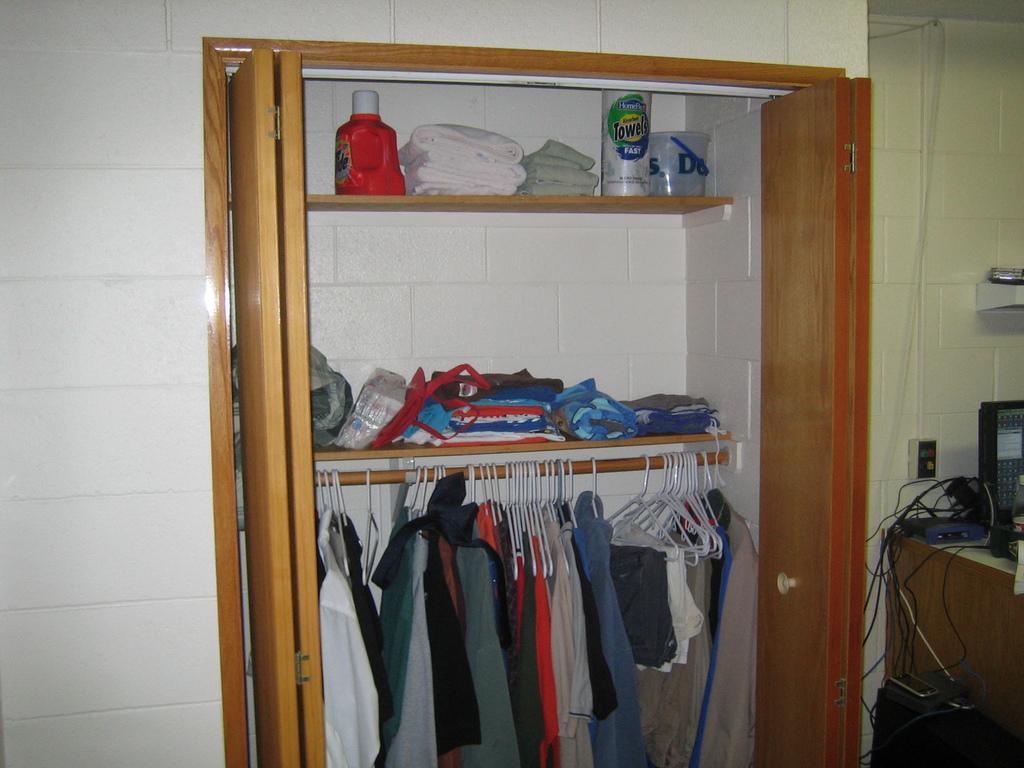Describe this image in one or two sentences. In this image there is a cupboard, there are objects in the cupboard, there are clothes in the cupboard, there are objects towards the right of the image, there is a wire, at the background of the image there is a wall, the background of the image is white in color. 